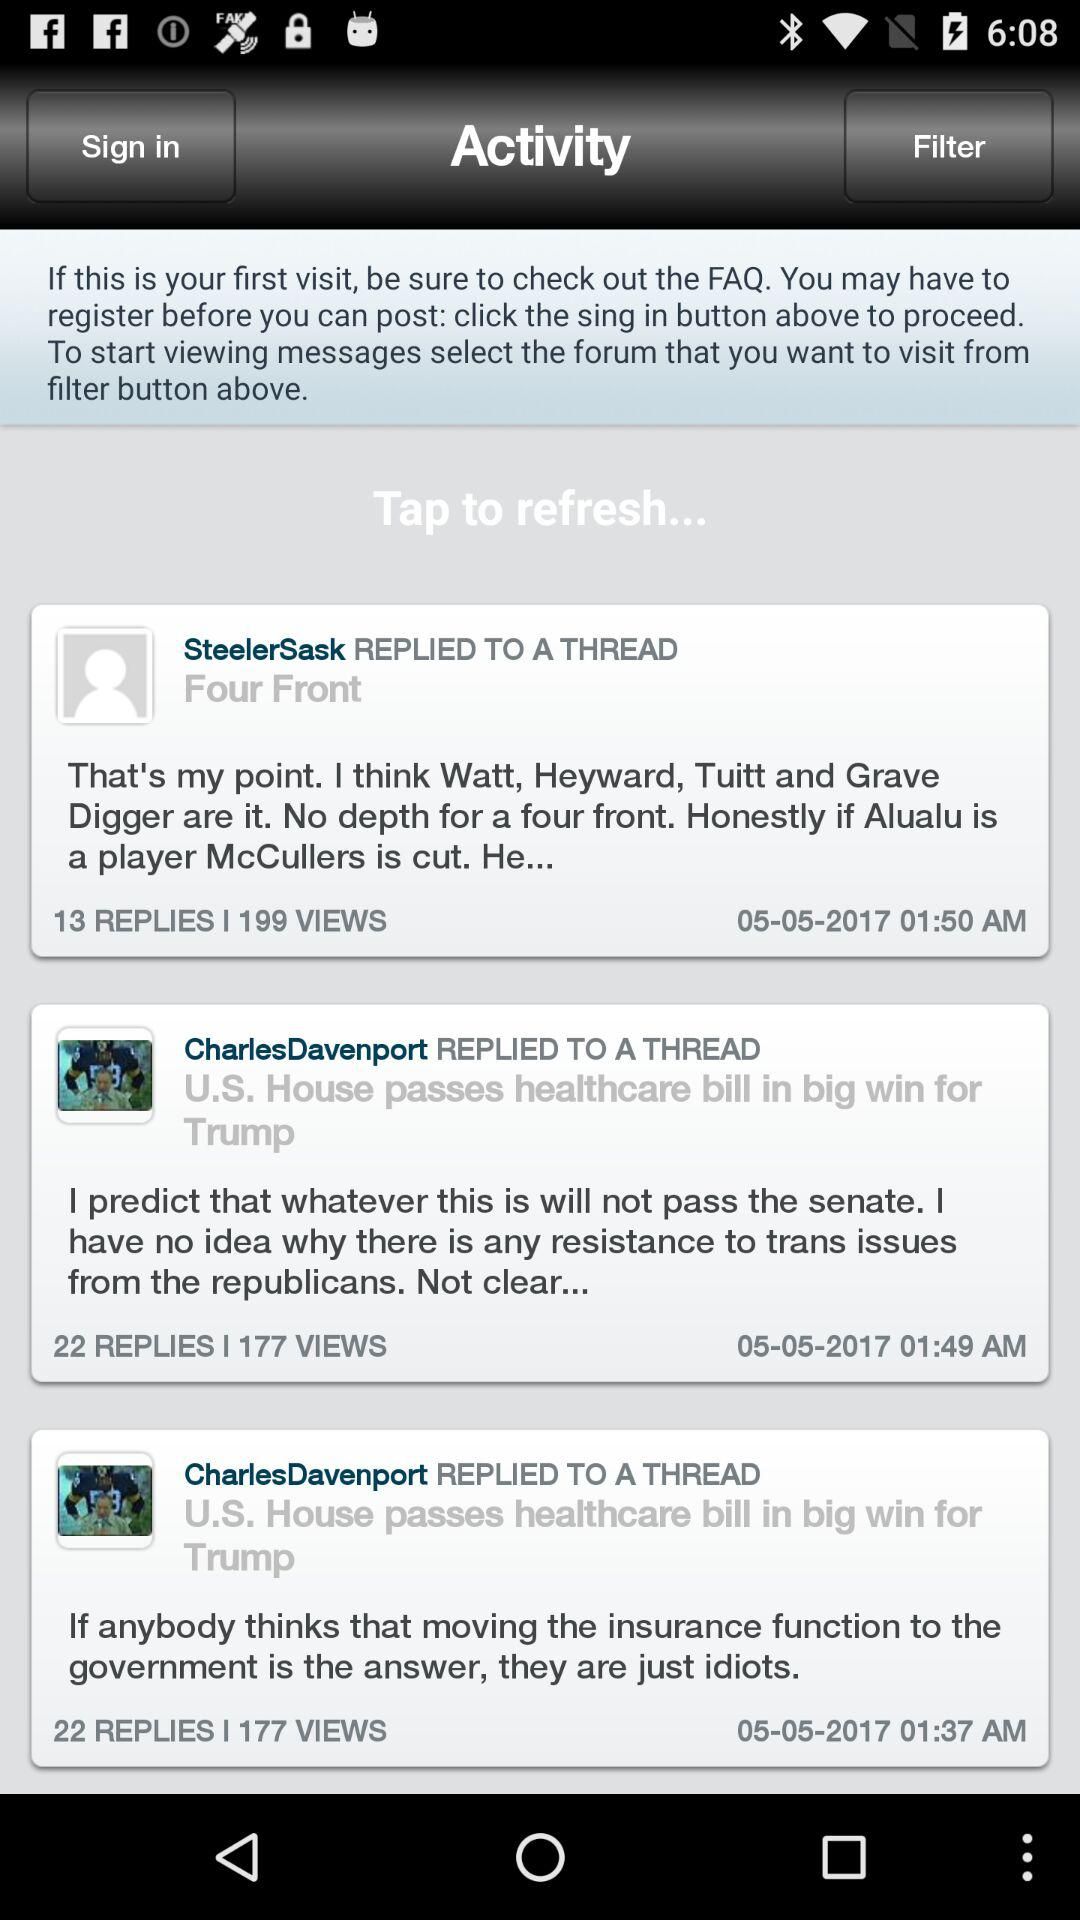How many views are there on "SteelerSask REPLIED TO A THREAD"? There are 199 views. 